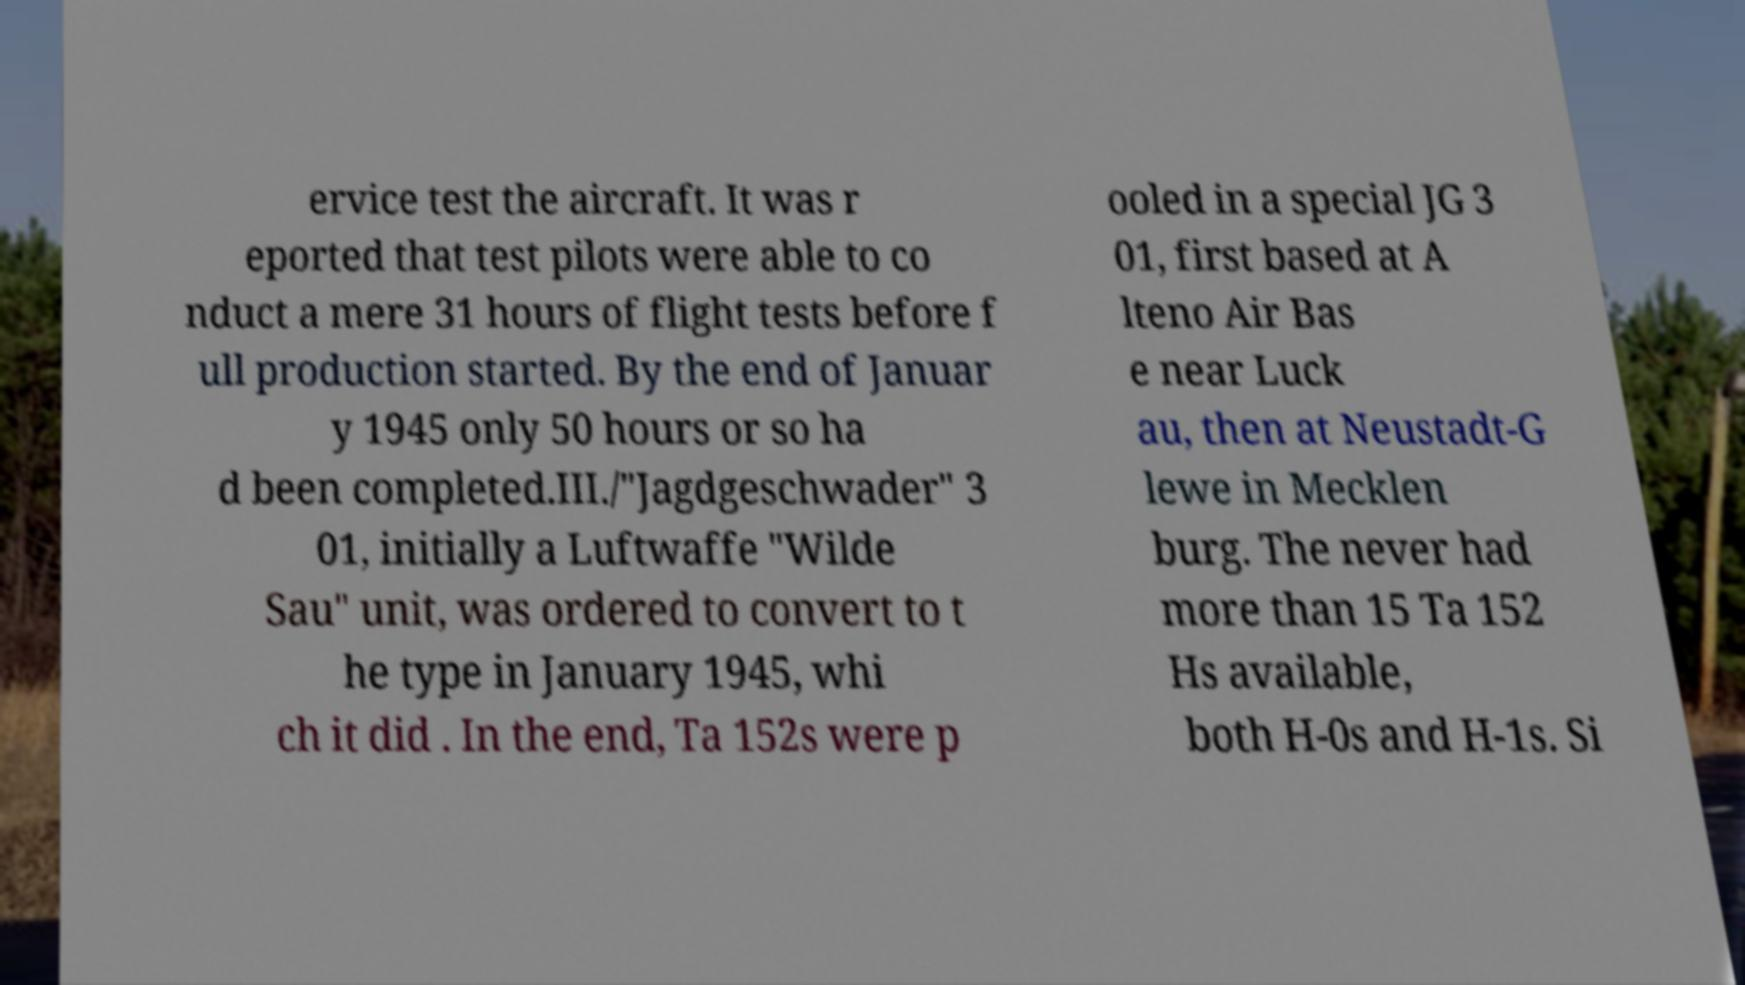There's text embedded in this image that I need extracted. Can you transcribe it verbatim? ervice test the aircraft. It was r eported that test pilots were able to co nduct a mere 31 hours of flight tests before f ull production started. By the end of Januar y 1945 only 50 hours or so ha d been completed.III./"Jagdgeschwader" 3 01, initially a Luftwaffe "Wilde Sau" unit, was ordered to convert to t he type in January 1945, whi ch it did . In the end, Ta 152s were p ooled in a special JG 3 01, first based at A lteno Air Bas e near Luck au, then at Neustadt-G lewe in Mecklen burg. The never had more than 15 Ta 152 Hs available, both H-0s and H-1s. Si 